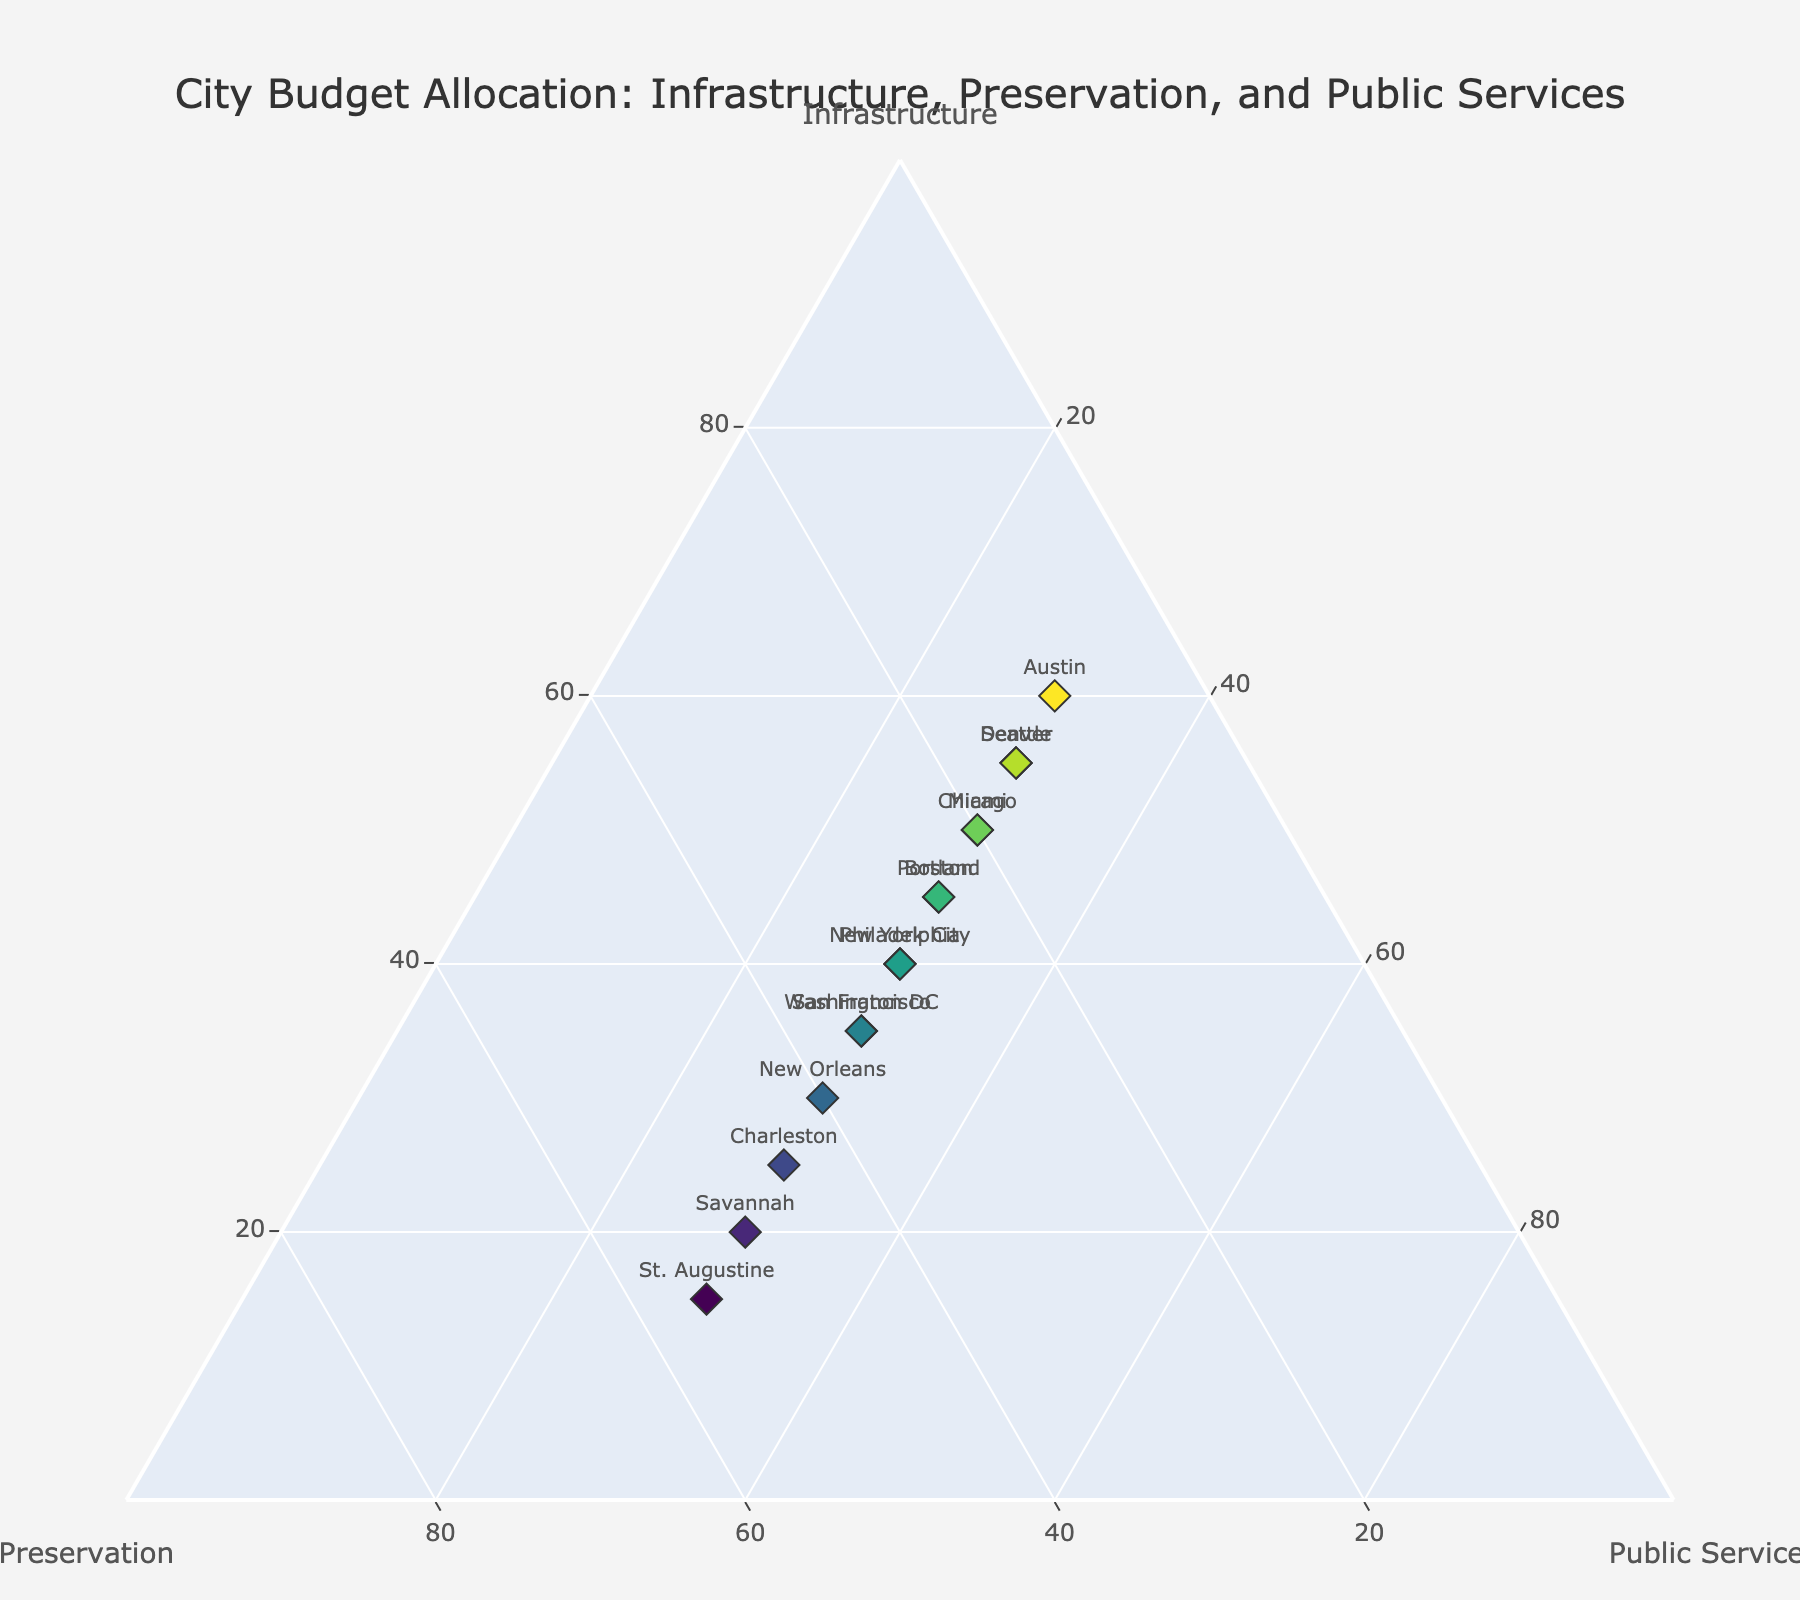How many cities allocate more of their budget to historical preservation than to infrastructure? To determine this, we compare the 'Preservation' and 'Infrastructure' values for each city. The cities where 'Preservation' exceeds 'Infrastructure' are San Francisco, New Orleans, Charleston, Savannah, and St. Augustine. There are 5 such cities.
Answer: 5 Which city has the highest budget allocation to infrastructure development? Among the cities listed, Austin has the highest percentage allocated to infrastructure development at 60%.
Answer: Austin What is the minimum budget allocation for public services across all cities? We list the 'Public Services' values and identify the minimum, which is 30% for all cities.
Answer: 30% How does Boston's budget allocation compare with Chicago's in terms of historical preservation? Boston allocates 25% to historical preservation, while Chicago allocates 20%. Therefore, Boston allocates 5% more to historical preservation than Chicago.
Answer: Boston allocates 5% more Which city has balanced allocations (values are the closest) among the three budget categories? We look for cities where the differences among 'Infrastructure', 'Preservation', and 'Public Services' are the smallest. Philadelphia and New York City both have 40% for infrastructure, 30% for preservation, and 30% for public services, making their budget allocations the most balanced.
Answer: Philadelphia and New York City If the average budget allocation for infrastructure development across all cities is calculated, what is the result? To find the average, sum the 'Infrastructure' percentages (45+50+35+30+55+40+25+60+20+45+35+40+55+50+15 = 600%) and divide by the number of cities, which is 15. The average is 600% / 15 = 40%.
Answer: 40% Which city is the outlier that significantly prioritizes historical preservation over infrastructure development? St. Augustine allocates 15% to infrastructure and 55% to historical preservation, showing a significant priority toward preservation.
Answer: St. Augustine Compare the combined budget allocation for preservation and public services in Seattle and Denver. Which city allocates a higher combined percentage? In Seattle, the combined allocation for preservation (15%) and public services (30%) is 45%. In Denver, it is the same: 15% (preservation) + 30% (public services) = 45%. Both cities have the same combined percentage.
Answer: Both are equal 